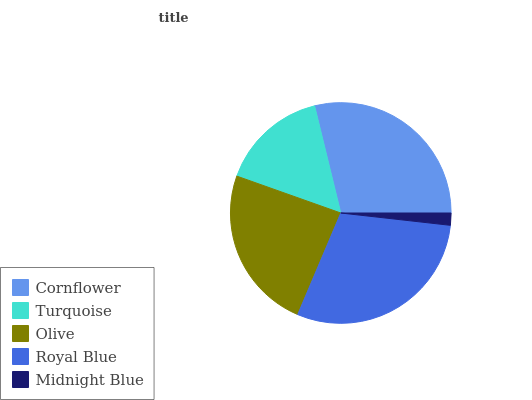Is Midnight Blue the minimum?
Answer yes or no. Yes. Is Royal Blue the maximum?
Answer yes or no. Yes. Is Turquoise the minimum?
Answer yes or no. No. Is Turquoise the maximum?
Answer yes or no. No. Is Cornflower greater than Turquoise?
Answer yes or no. Yes. Is Turquoise less than Cornflower?
Answer yes or no. Yes. Is Turquoise greater than Cornflower?
Answer yes or no. No. Is Cornflower less than Turquoise?
Answer yes or no. No. Is Olive the high median?
Answer yes or no. Yes. Is Olive the low median?
Answer yes or no. Yes. Is Cornflower the high median?
Answer yes or no. No. Is Turquoise the low median?
Answer yes or no. No. 